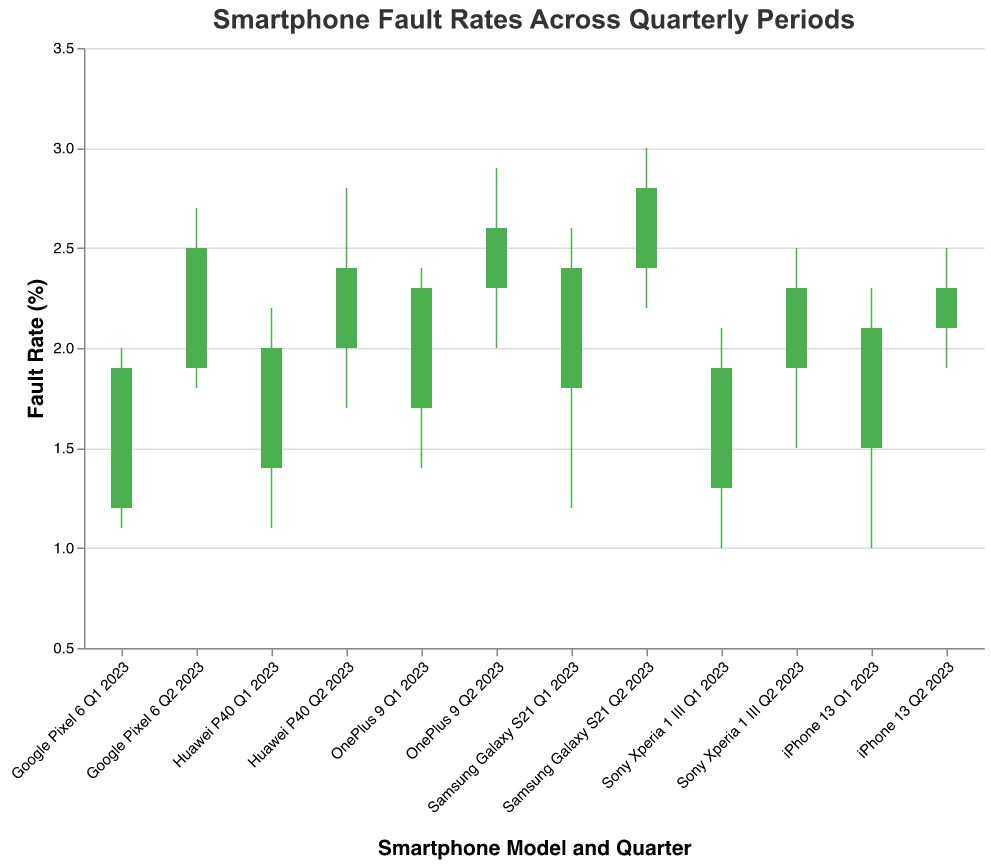What is the title of the plot? The title of the plot is usually located at the top of the chart and provides a brief description of the data being visualized.
Answer: Smartphone Fault Rates Across Quarterly Periods How many smartphone models are represented in the plot? Each unique combination of model and quarter represents a data point. By counting the number of such combinations, we can determine the number of models.
Answer: 6 Which quarter shows the highest fault rate for iPhone 13? To find the highest fault rate for iPhone 13, compare the high values for each quarter. The quarter with the highest "High" value will have the highest fault rate.
Answer: 2023Q2 Which smartphone model had the greatest increase in fault rate from Q1 2023 to Q2 2023? Calculate the difference between the "Close" values of Q2 2023 and Q1 2023 for each model. The model with the highest positive difference had the greatest increase.
Answer: Google Pixel 6 Which smartphone model had the highest fault rate in 2023Q1? Identify the model with the highest "High" value in 2023Q1.
Answer: Samsung Galaxy S21 Do any models show a decrease in fault rate from Q1 2023 to Q2 2023? Compare the "Close" values of Q1 2023 and Q2 2023 for each model. A decrease is indicated if the "Close" value of Q2 2023 is less than the "Close" value of Q1 2023.
Answer: No Which model maintained a steady climb (increase) in its fault rate from Q1 2023 to Q2 2023? A steady climb is indicated if both the "Open" to "Close" values, and "Close" values of Q2 2023 are higher than those of Q1 2023. Compare these values for each model.
Answer: iPhone 13 What are the maximum and minimum fault rates observed in the plot? The maximum fault rate corresponds to the highest "High" value, and the minimum fault rate corresponds to the lowest "Low" value across all data points.
Answer: Maximum: 3.0, Minimum: 1.0 Which model had the least variance in its fault rates in Q1 2023? Variance in a quarter can be observed from the difference between the "High" and "Low" values. The model with the smallest difference in 2023Q1 has the least variance.
Answer: Google Pixel 6 How many models showed improvement in fault rates from Q1 to Q2 2023? Improvement in fault rates is indicated if the "Open" value of Q2 2023 is higher and the "Close" value of Q2 2023 is lower compared to Q1 2023. Count the models meeting this criterion.
Answer: 0 